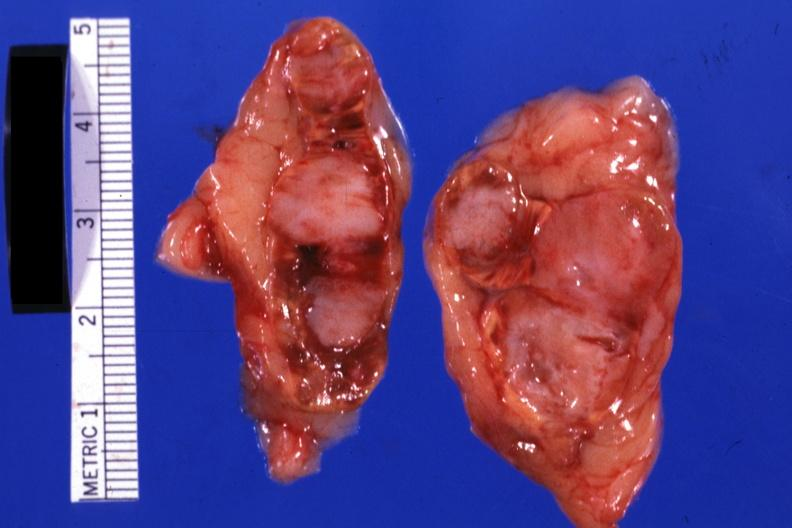what is present?
Answer the question using a single word or phrase. Endocrine 